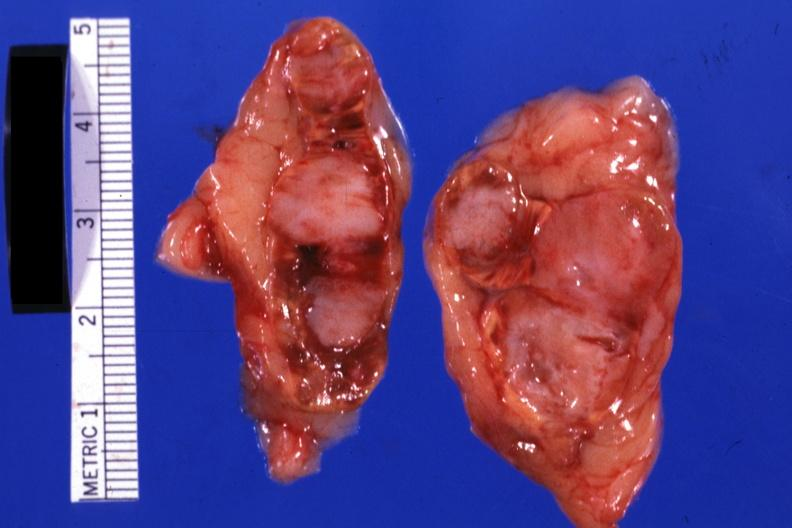what is present?
Answer the question using a single word or phrase. Endocrine 